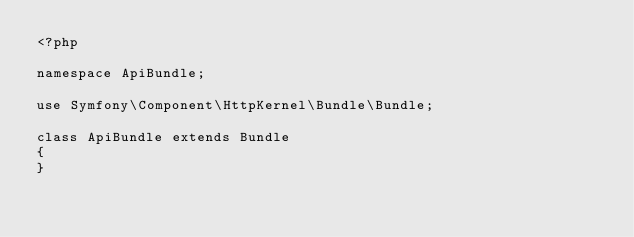Convert code to text. <code><loc_0><loc_0><loc_500><loc_500><_PHP_><?php

namespace ApiBundle;

use Symfony\Component\HttpKernel\Bundle\Bundle;

class ApiBundle extends Bundle
{
}
</code> 